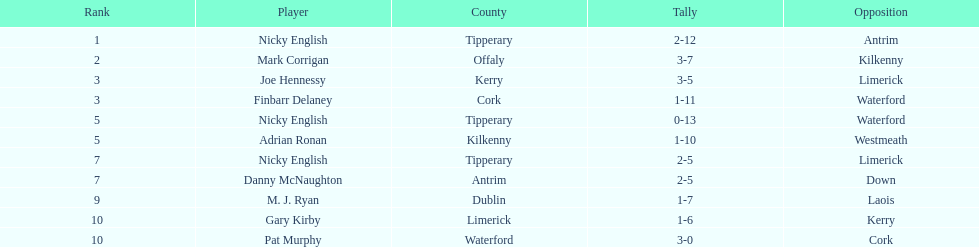Who was the top ranked player in a single game? Nicky English. 